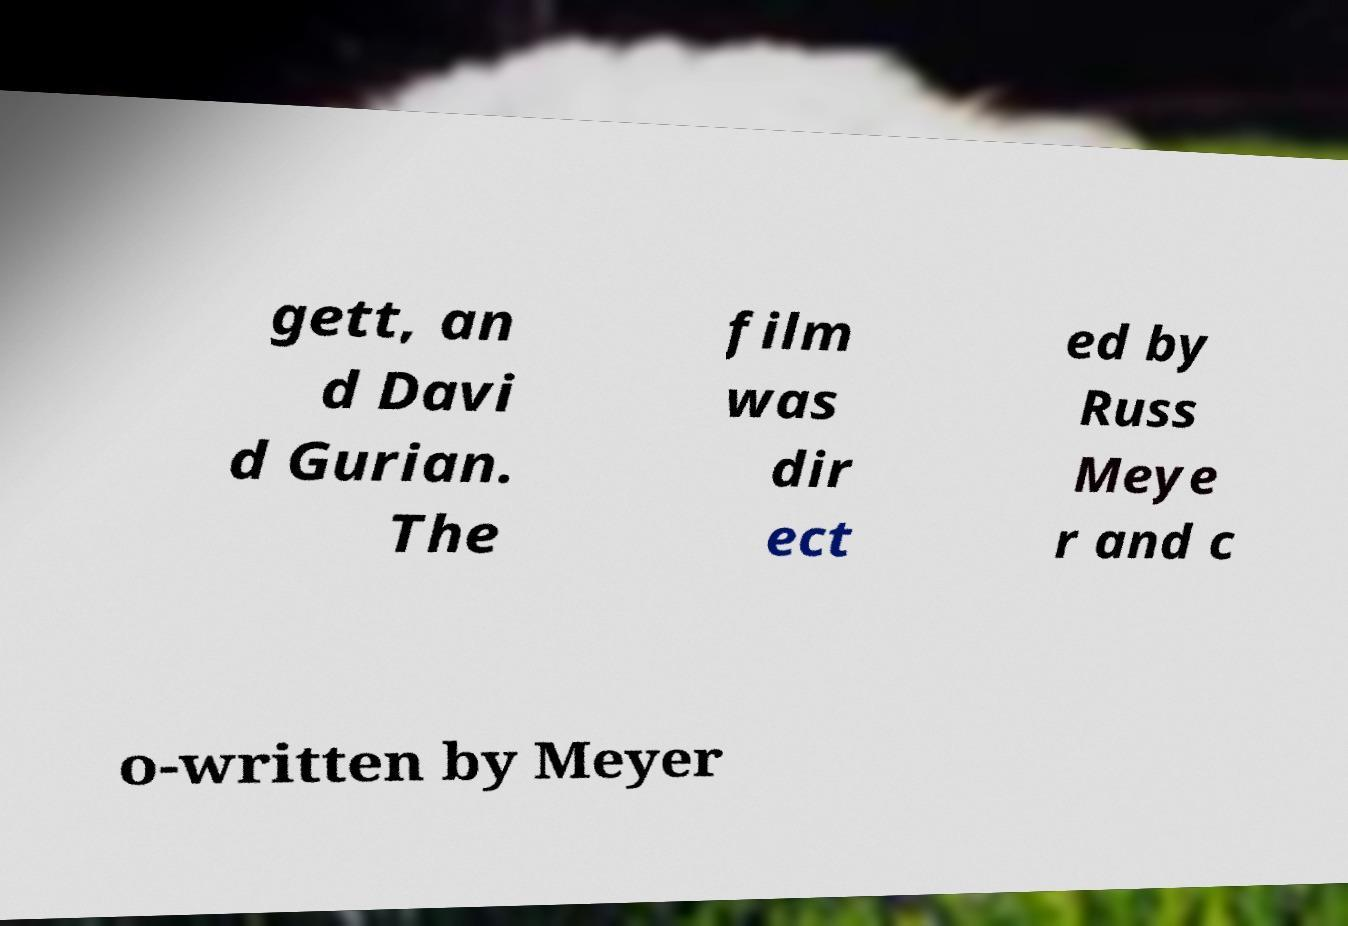What messages or text are displayed in this image? I need them in a readable, typed format. gett, an d Davi d Gurian. The film was dir ect ed by Russ Meye r and c o-written by Meyer 